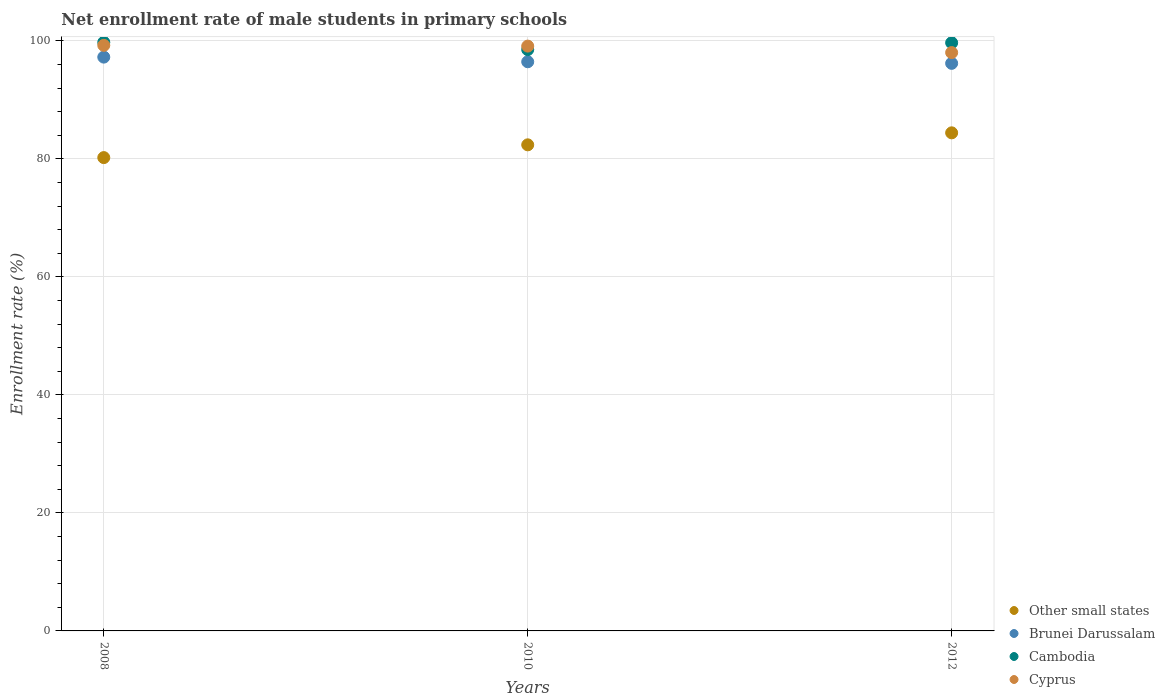How many different coloured dotlines are there?
Offer a very short reply. 4. Is the number of dotlines equal to the number of legend labels?
Offer a terse response. Yes. What is the net enrollment rate of male students in primary schools in Brunei Darussalam in 2010?
Provide a short and direct response. 96.46. Across all years, what is the maximum net enrollment rate of male students in primary schools in Cyprus?
Your answer should be compact. 99.24. Across all years, what is the minimum net enrollment rate of male students in primary schools in Cyprus?
Your answer should be compact. 98.02. What is the total net enrollment rate of male students in primary schools in Other small states in the graph?
Make the answer very short. 247.01. What is the difference between the net enrollment rate of male students in primary schools in Brunei Darussalam in 2008 and that in 2010?
Offer a terse response. 0.79. What is the difference between the net enrollment rate of male students in primary schools in Other small states in 2012 and the net enrollment rate of male students in primary schools in Cyprus in 2010?
Make the answer very short. -14.7. What is the average net enrollment rate of male students in primary schools in Cambodia per year?
Provide a succinct answer. 99.32. In the year 2010, what is the difference between the net enrollment rate of male students in primary schools in Cyprus and net enrollment rate of male students in primary schools in Brunei Darussalam?
Keep it short and to the point. 2.65. What is the ratio of the net enrollment rate of male students in primary schools in Cyprus in 2008 to that in 2010?
Your answer should be compact. 1. Is the net enrollment rate of male students in primary schools in Other small states in 2010 less than that in 2012?
Your response must be concise. Yes. What is the difference between the highest and the second highest net enrollment rate of male students in primary schools in Cambodia?
Your response must be concise. 0.07. What is the difference between the highest and the lowest net enrollment rate of male students in primary schools in Other small states?
Your answer should be compact. 4.2. In how many years, is the net enrollment rate of male students in primary schools in Other small states greater than the average net enrollment rate of male students in primary schools in Other small states taken over all years?
Your response must be concise. 2. Is the sum of the net enrollment rate of male students in primary schools in Other small states in 2008 and 2012 greater than the maximum net enrollment rate of male students in primary schools in Cyprus across all years?
Keep it short and to the point. Yes. Is it the case that in every year, the sum of the net enrollment rate of male students in primary schools in Brunei Darussalam and net enrollment rate of male students in primary schools in Other small states  is greater than the net enrollment rate of male students in primary schools in Cyprus?
Your response must be concise. Yes. Does the net enrollment rate of male students in primary schools in Brunei Darussalam monotonically increase over the years?
Your answer should be compact. No. What is the difference between two consecutive major ticks on the Y-axis?
Provide a succinct answer. 20. How many legend labels are there?
Offer a very short reply. 4. What is the title of the graph?
Provide a short and direct response. Net enrollment rate of male students in primary schools. What is the label or title of the X-axis?
Your answer should be compact. Years. What is the label or title of the Y-axis?
Provide a short and direct response. Enrollment rate (%). What is the Enrollment rate (%) in Other small states in 2008?
Offer a terse response. 80.22. What is the Enrollment rate (%) of Brunei Darussalam in 2008?
Provide a short and direct response. 97.25. What is the Enrollment rate (%) in Cambodia in 2008?
Offer a terse response. 99.75. What is the Enrollment rate (%) of Cyprus in 2008?
Keep it short and to the point. 99.24. What is the Enrollment rate (%) of Other small states in 2010?
Offer a terse response. 82.38. What is the Enrollment rate (%) of Brunei Darussalam in 2010?
Your response must be concise. 96.46. What is the Enrollment rate (%) in Cambodia in 2010?
Offer a very short reply. 98.52. What is the Enrollment rate (%) in Cyprus in 2010?
Offer a terse response. 99.12. What is the Enrollment rate (%) in Other small states in 2012?
Keep it short and to the point. 84.41. What is the Enrollment rate (%) of Brunei Darussalam in 2012?
Your answer should be compact. 96.19. What is the Enrollment rate (%) of Cambodia in 2012?
Your response must be concise. 99.68. What is the Enrollment rate (%) in Cyprus in 2012?
Provide a succinct answer. 98.02. Across all years, what is the maximum Enrollment rate (%) of Other small states?
Your answer should be very brief. 84.41. Across all years, what is the maximum Enrollment rate (%) in Brunei Darussalam?
Keep it short and to the point. 97.25. Across all years, what is the maximum Enrollment rate (%) of Cambodia?
Your answer should be compact. 99.75. Across all years, what is the maximum Enrollment rate (%) of Cyprus?
Your answer should be compact. 99.24. Across all years, what is the minimum Enrollment rate (%) in Other small states?
Your answer should be compact. 80.22. Across all years, what is the minimum Enrollment rate (%) of Brunei Darussalam?
Your answer should be very brief. 96.19. Across all years, what is the minimum Enrollment rate (%) in Cambodia?
Offer a terse response. 98.52. Across all years, what is the minimum Enrollment rate (%) of Cyprus?
Your answer should be compact. 98.02. What is the total Enrollment rate (%) of Other small states in the graph?
Provide a succinct answer. 247.01. What is the total Enrollment rate (%) of Brunei Darussalam in the graph?
Keep it short and to the point. 289.9. What is the total Enrollment rate (%) of Cambodia in the graph?
Keep it short and to the point. 297.95. What is the total Enrollment rate (%) in Cyprus in the graph?
Offer a terse response. 296.37. What is the difference between the Enrollment rate (%) of Other small states in 2008 and that in 2010?
Your response must be concise. -2.16. What is the difference between the Enrollment rate (%) of Brunei Darussalam in 2008 and that in 2010?
Offer a terse response. 0.79. What is the difference between the Enrollment rate (%) of Cambodia in 2008 and that in 2010?
Give a very brief answer. 1.24. What is the difference between the Enrollment rate (%) of Cyprus in 2008 and that in 2010?
Keep it short and to the point. 0.13. What is the difference between the Enrollment rate (%) in Other small states in 2008 and that in 2012?
Provide a succinct answer. -4.2. What is the difference between the Enrollment rate (%) of Brunei Darussalam in 2008 and that in 2012?
Your answer should be very brief. 1.06. What is the difference between the Enrollment rate (%) of Cambodia in 2008 and that in 2012?
Offer a terse response. 0.07. What is the difference between the Enrollment rate (%) of Cyprus in 2008 and that in 2012?
Provide a short and direct response. 1.23. What is the difference between the Enrollment rate (%) in Other small states in 2010 and that in 2012?
Keep it short and to the point. -2.03. What is the difference between the Enrollment rate (%) in Brunei Darussalam in 2010 and that in 2012?
Keep it short and to the point. 0.27. What is the difference between the Enrollment rate (%) in Cambodia in 2010 and that in 2012?
Provide a succinct answer. -1.16. What is the difference between the Enrollment rate (%) in Cyprus in 2010 and that in 2012?
Provide a short and direct response. 1.1. What is the difference between the Enrollment rate (%) in Other small states in 2008 and the Enrollment rate (%) in Brunei Darussalam in 2010?
Provide a short and direct response. -16.24. What is the difference between the Enrollment rate (%) of Other small states in 2008 and the Enrollment rate (%) of Cambodia in 2010?
Provide a succinct answer. -18.3. What is the difference between the Enrollment rate (%) in Other small states in 2008 and the Enrollment rate (%) in Cyprus in 2010?
Provide a short and direct response. -18.9. What is the difference between the Enrollment rate (%) of Brunei Darussalam in 2008 and the Enrollment rate (%) of Cambodia in 2010?
Give a very brief answer. -1.27. What is the difference between the Enrollment rate (%) in Brunei Darussalam in 2008 and the Enrollment rate (%) in Cyprus in 2010?
Offer a terse response. -1.87. What is the difference between the Enrollment rate (%) of Cambodia in 2008 and the Enrollment rate (%) of Cyprus in 2010?
Your answer should be compact. 0.64. What is the difference between the Enrollment rate (%) in Other small states in 2008 and the Enrollment rate (%) in Brunei Darussalam in 2012?
Your response must be concise. -15.97. What is the difference between the Enrollment rate (%) of Other small states in 2008 and the Enrollment rate (%) of Cambodia in 2012?
Offer a very short reply. -19.46. What is the difference between the Enrollment rate (%) in Other small states in 2008 and the Enrollment rate (%) in Cyprus in 2012?
Provide a succinct answer. -17.8. What is the difference between the Enrollment rate (%) in Brunei Darussalam in 2008 and the Enrollment rate (%) in Cambodia in 2012?
Offer a very short reply. -2.43. What is the difference between the Enrollment rate (%) of Brunei Darussalam in 2008 and the Enrollment rate (%) of Cyprus in 2012?
Make the answer very short. -0.77. What is the difference between the Enrollment rate (%) of Cambodia in 2008 and the Enrollment rate (%) of Cyprus in 2012?
Give a very brief answer. 1.74. What is the difference between the Enrollment rate (%) in Other small states in 2010 and the Enrollment rate (%) in Brunei Darussalam in 2012?
Offer a very short reply. -13.81. What is the difference between the Enrollment rate (%) in Other small states in 2010 and the Enrollment rate (%) in Cambodia in 2012?
Your answer should be compact. -17.3. What is the difference between the Enrollment rate (%) of Other small states in 2010 and the Enrollment rate (%) of Cyprus in 2012?
Provide a succinct answer. -15.63. What is the difference between the Enrollment rate (%) of Brunei Darussalam in 2010 and the Enrollment rate (%) of Cambodia in 2012?
Your response must be concise. -3.22. What is the difference between the Enrollment rate (%) of Brunei Darussalam in 2010 and the Enrollment rate (%) of Cyprus in 2012?
Your answer should be very brief. -1.56. What is the difference between the Enrollment rate (%) in Cambodia in 2010 and the Enrollment rate (%) in Cyprus in 2012?
Ensure brevity in your answer.  0.5. What is the average Enrollment rate (%) of Other small states per year?
Provide a succinct answer. 82.34. What is the average Enrollment rate (%) in Brunei Darussalam per year?
Ensure brevity in your answer.  96.63. What is the average Enrollment rate (%) of Cambodia per year?
Ensure brevity in your answer.  99.32. What is the average Enrollment rate (%) in Cyprus per year?
Keep it short and to the point. 98.79. In the year 2008, what is the difference between the Enrollment rate (%) of Other small states and Enrollment rate (%) of Brunei Darussalam?
Keep it short and to the point. -17.03. In the year 2008, what is the difference between the Enrollment rate (%) in Other small states and Enrollment rate (%) in Cambodia?
Your answer should be compact. -19.53. In the year 2008, what is the difference between the Enrollment rate (%) in Other small states and Enrollment rate (%) in Cyprus?
Make the answer very short. -19.02. In the year 2008, what is the difference between the Enrollment rate (%) in Brunei Darussalam and Enrollment rate (%) in Cambodia?
Make the answer very short. -2.5. In the year 2008, what is the difference between the Enrollment rate (%) in Brunei Darussalam and Enrollment rate (%) in Cyprus?
Your answer should be compact. -1.99. In the year 2008, what is the difference between the Enrollment rate (%) in Cambodia and Enrollment rate (%) in Cyprus?
Your answer should be very brief. 0.51. In the year 2010, what is the difference between the Enrollment rate (%) in Other small states and Enrollment rate (%) in Brunei Darussalam?
Your answer should be very brief. -14.08. In the year 2010, what is the difference between the Enrollment rate (%) in Other small states and Enrollment rate (%) in Cambodia?
Give a very brief answer. -16.14. In the year 2010, what is the difference between the Enrollment rate (%) of Other small states and Enrollment rate (%) of Cyprus?
Keep it short and to the point. -16.73. In the year 2010, what is the difference between the Enrollment rate (%) in Brunei Darussalam and Enrollment rate (%) in Cambodia?
Ensure brevity in your answer.  -2.06. In the year 2010, what is the difference between the Enrollment rate (%) of Brunei Darussalam and Enrollment rate (%) of Cyprus?
Give a very brief answer. -2.65. In the year 2010, what is the difference between the Enrollment rate (%) of Cambodia and Enrollment rate (%) of Cyprus?
Provide a short and direct response. -0.6. In the year 2012, what is the difference between the Enrollment rate (%) of Other small states and Enrollment rate (%) of Brunei Darussalam?
Your answer should be compact. -11.78. In the year 2012, what is the difference between the Enrollment rate (%) of Other small states and Enrollment rate (%) of Cambodia?
Offer a terse response. -15.27. In the year 2012, what is the difference between the Enrollment rate (%) of Other small states and Enrollment rate (%) of Cyprus?
Provide a succinct answer. -13.6. In the year 2012, what is the difference between the Enrollment rate (%) of Brunei Darussalam and Enrollment rate (%) of Cambodia?
Your answer should be very brief. -3.49. In the year 2012, what is the difference between the Enrollment rate (%) of Brunei Darussalam and Enrollment rate (%) of Cyprus?
Provide a short and direct response. -1.83. In the year 2012, what is the difference between the Enrollment rate (%) in Cambodia and Enrollment rate (%) in Cyprus?
Offer a very short reply. 1.66. What is the ratio of the Enrollment rate (%) in Other small states in 2008 to that in 2010?
Provide a short and direct response. 0.97. What is the ratio of the Enrollment rate (%) of Brunei Darussalam in 2008 to that in 2010?
Your response must be concise. 1.01. What is the ratio of the Enrollment rate (%) in Cambodia in 2008 to that in 2010?
Ensure brevity in your answer.  1.01. What is the ratio of the Enrollment rate (%) in Cyprus in 2008 to that in 2010?
Offer a terse response. 1. What is the ratio of the Enrollment rate (%) in Other small states in 2008 to that in 2012?
Your answer should be very brief. 0.95. What is the ratio of the Enrollment rate (%) of Cambodia in 2008 to that in 2012?
Your response must be concise. 1. What is the ratio of the Enrollment rate (%) in Cyprus in 2008 to that in 2012?
Provide a short and direct response. 1.01. What is the ratio of the Enrollment rate (%) of Other small states in 2010 to that in 2012?
Offer a terse response. 0.98. What is the ratio of the Enrollment rate (%) in Cambodia in 2010 to that in 2012?
Provide a succinct answer. 0.99. What is the ratio of the Enrollment rate (%) of Cyprus in 2010 to that in 2012?
Make the answer very short. 1.01. What is the difference between the highest and the second highest Enrollment rate (%) of Other small states?
Your answer should be very brief. 2.03. What is the difference between the highest and the second highest Enrollment rate (%) of Brunei Darussalam?
Provide a succinct answer. 0.79. What is the difference between the highest and the second highest Enrollment rate (%) in Cambodia?
Ensure brevity in your answer.  0.07. What is the difference between the highest and the second highest Enrollment rate (%) of Cyprus?
Your answer should be very brief. 0.13. What is the difference between the highest and the lowest Enrollment rate (%) in Other small states?
Provide a short and direct response. 4.2. What is the difference between the highest and the lowest Enrollment rate (%) in Brunei Darussalam?
Provide a succinct answer. 1.06. What is the difference between the highest and the lowest Enrollment rate (%) in Cambodia?
Give a very brief answer. 1.24. What is the difference between the highest and the lowest Enrollment rate (%) of Cyprus?
Give a very brief answer. 1.23. 